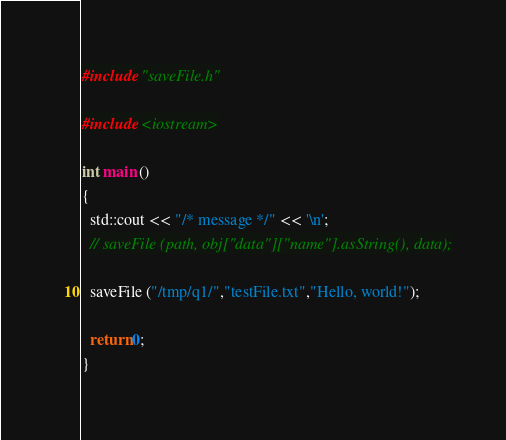<code> <loc_0><loc_0><loc_500><loc_500><_C++_>#include "saveFile.h"

#include <iostream>

int main ()
{
  std::cout << "/* message */" << '\n';
  // saveFile (path, obj["data"]["name"].asString(), data);

  saveFile ("/tmp/q1/","testFile.txt","Hello, world!");

  return 0;
}
</code> 